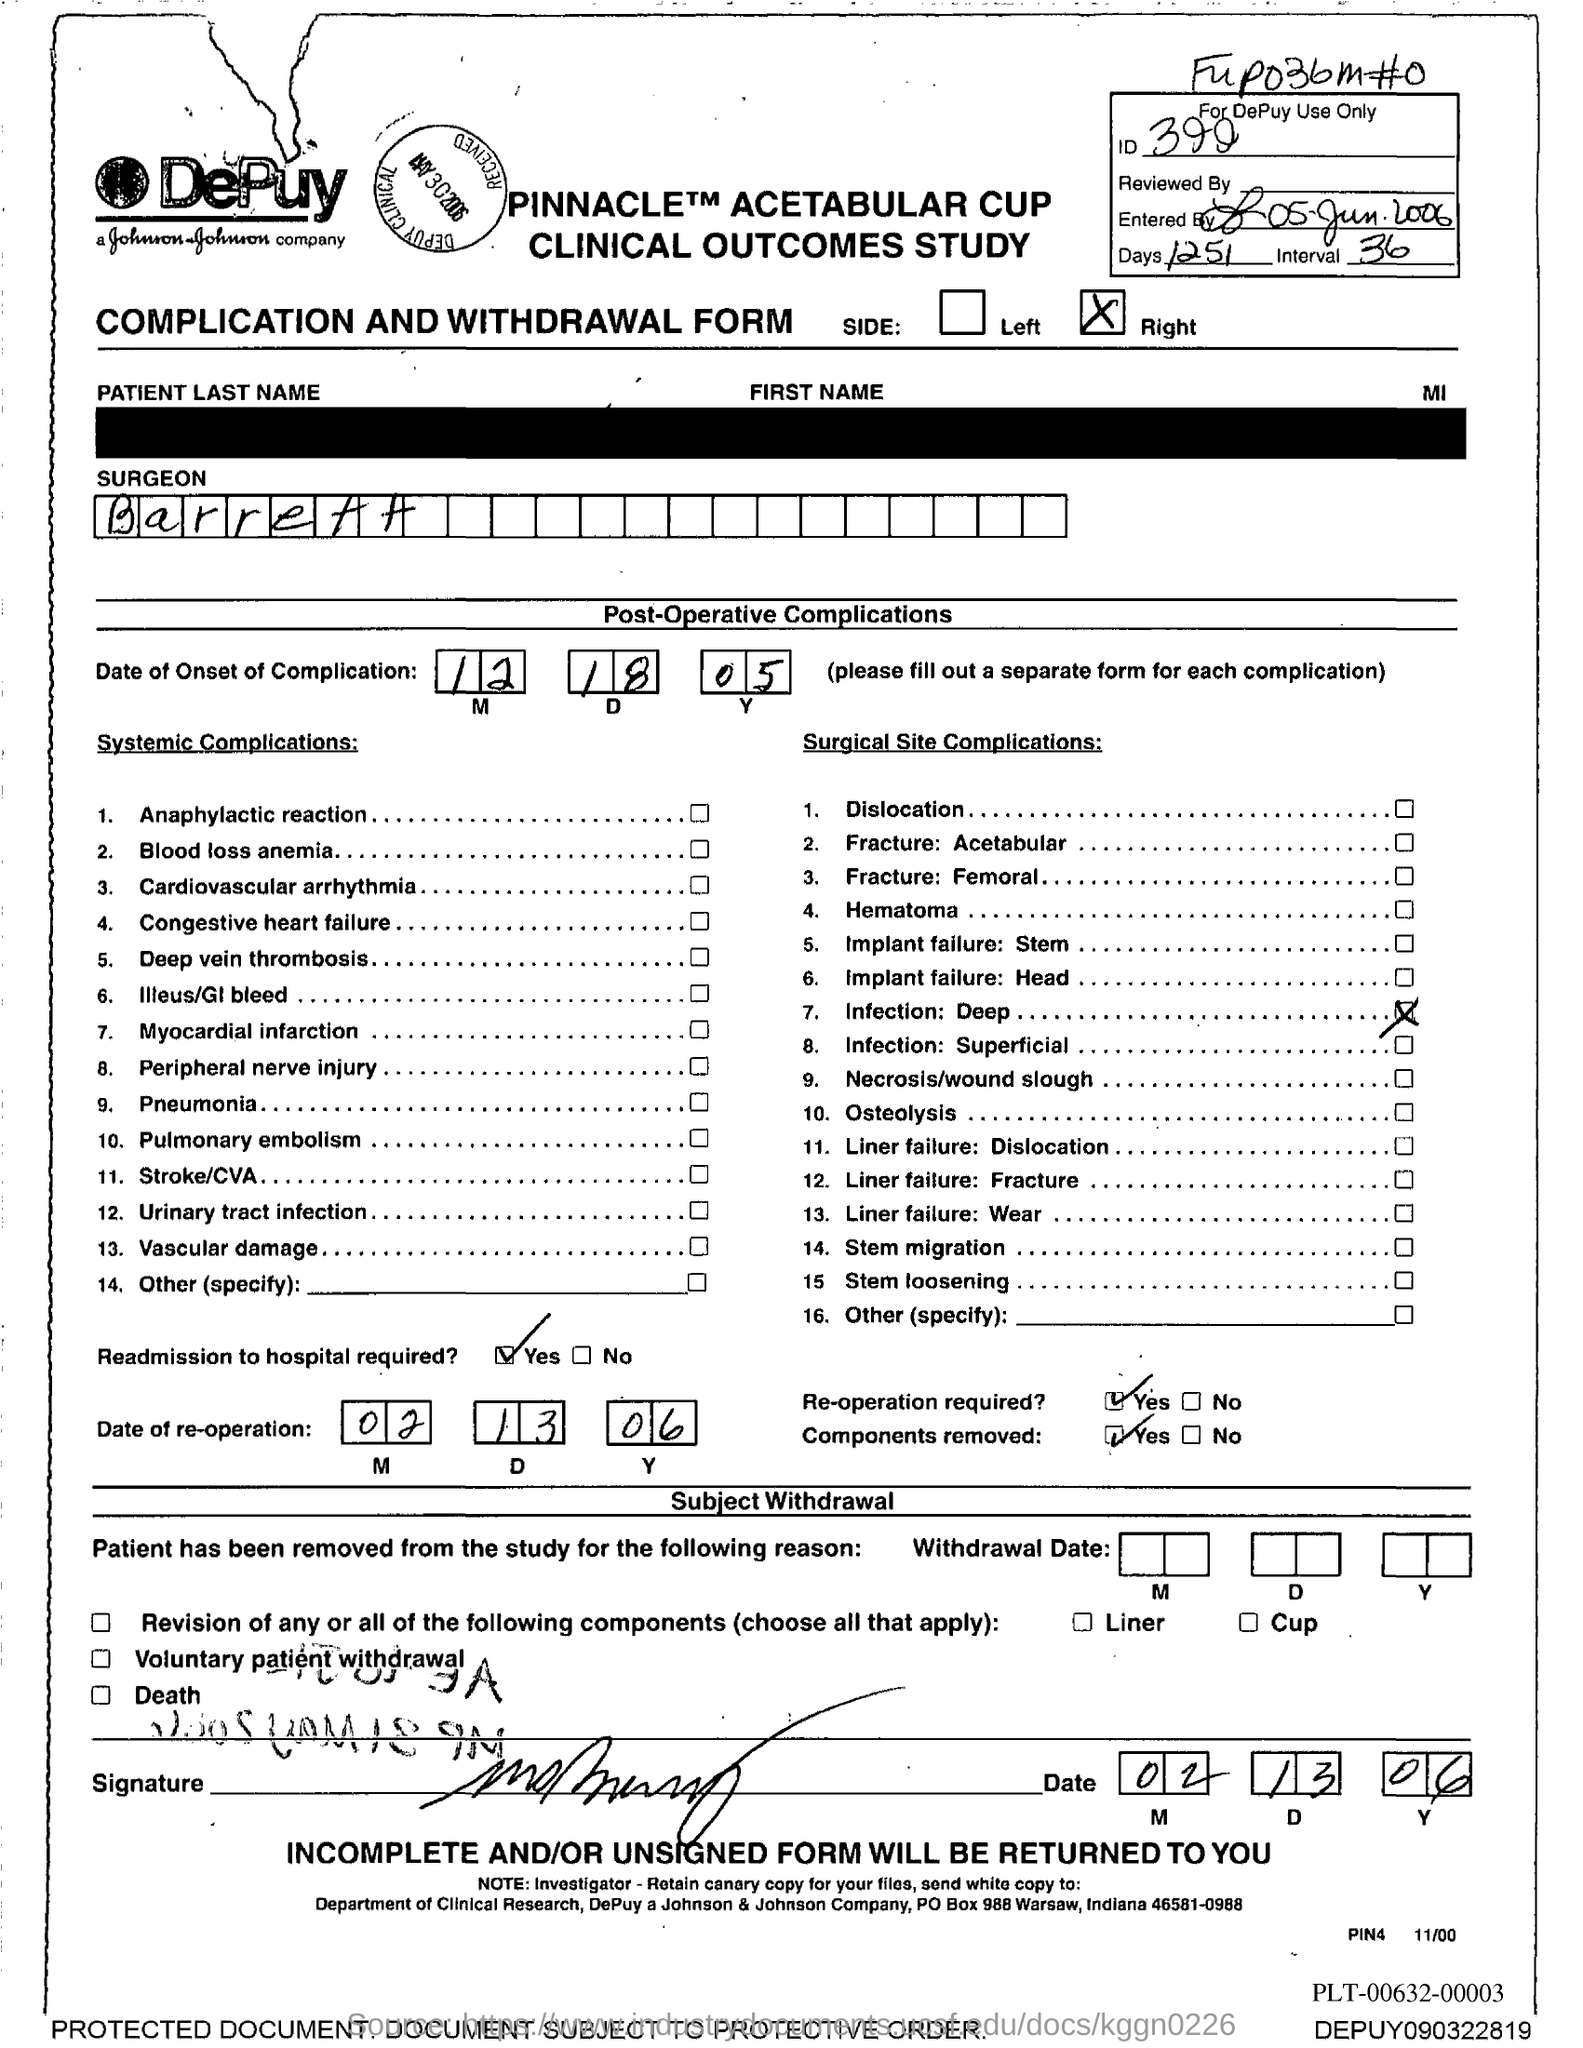What kind of form is this document?
Provide a succinct answer. COMPLICATION AND WITHDRAWAL FORM. What is written against number 2 under 'Systemic Complications'
Offer a very short reply. Blood loss anemia. What is the number of last item under heading Systemic Complications?
Ensure brevity in your answer.  14. What is mentioned along with number 12 under heading Systemic Complications?
Offer a very short reply. Urinary tract infection. What is written under 'SURGEON'?
Your answer should be very brief. Barrett. What is the PO Box number given?
Make the answer very short. 988 Warsaw. What is written against number 1 under 'Surgical Site Complications'?
Provide a short and direct response. Dislocation. What is written against number 10 under 'Surgical Site Complications'?
Ensure brevity in your answer.  Osteolysis. 